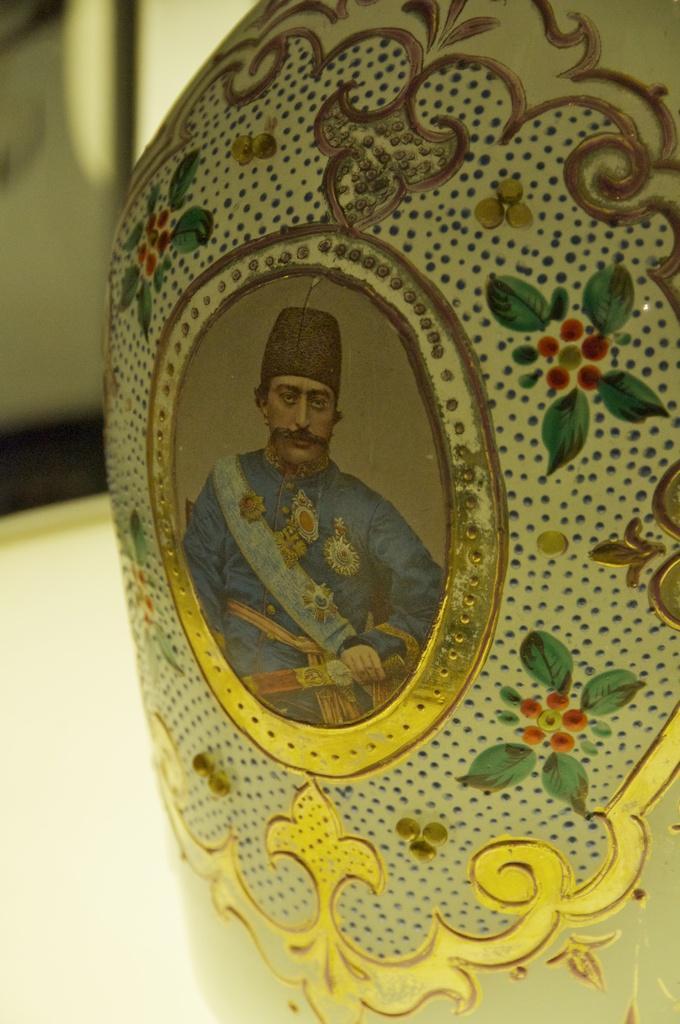Can you describe this image briefly? This image consists of a flower vase. On that there is a photo of a man, and there are flowers and leaves drawn with paint on that flower vase. 